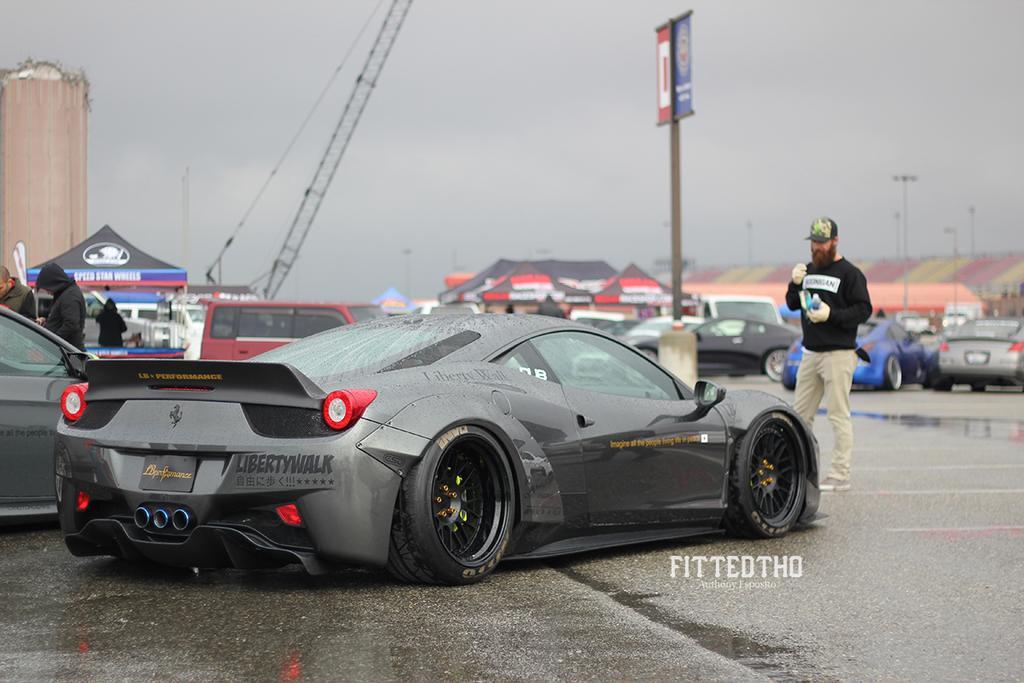In one or two sentences, can you explain what this image depicts? There are many vehicles on the road. There is a person wearing cap and gloves is holding something. Also there is a pole with a board. In the back there is sky, crane and buildings. 